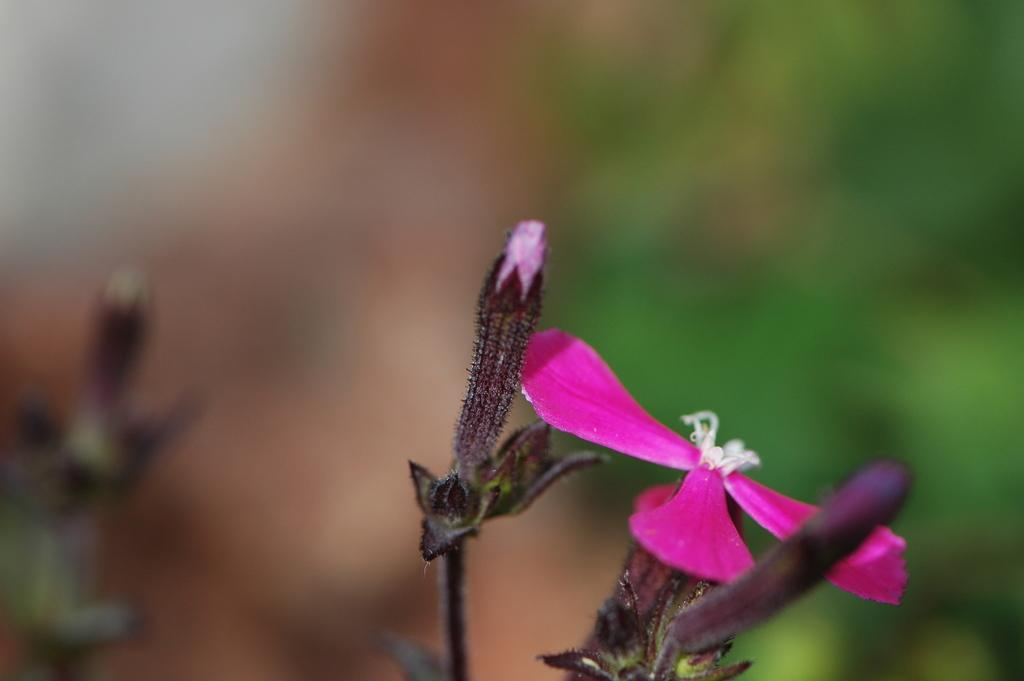What type of flower is in the image? There is a pink color flower in the image. What stage of growth is the flower in? The flower has buds. What color is the background of the image? The background is green and blurred. How much debt does the flower have in the image? There is no indication of debt in the image, as it features a flower with buds and a green background. 